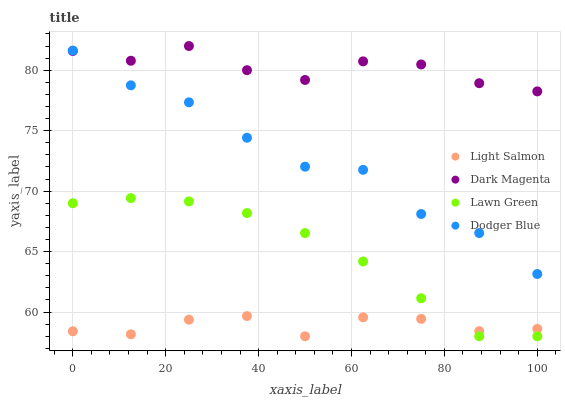Does Light Salmon have the minimum area under the curve?
Answer yes or no. Yes. Does Dark Magenta have the maximum area under the curve?
Answer yes or no. Yes. Does Dodger Blue have the minimum area under the curve?
Answer yes or no. No. Does Dodger Blue have the maximum area under the curve?
Answer yes or no. No. Is Lawn Green the smoothest?
Answer yes or no. Yes. Is Dodger Blue the roughest?
Answer yes or no. Yes. Is Light Salmon the smoothest?
Answer yes or no. No. Is Light Salmon the roughest?
Answer yes or no. No. Does Lawn Green have the lowest value?
Answer yes or no. Yes. Does Dodger Blue have the lowest value?
Answer yes or no. No. Does Dark Magenta have the highest value?
Answer yes or no. Yes. Does Dodger Blue have the highest value?
Answer yes or no. No. Is Lawn Green less than Dark Magenta?
Answer yes or no. Yes. Is Dodger Blue greater than Lawn Green?
Answer yes or no. Yes. Does Dodger Blue intersect Dark Magenta?
Answer yes or no. Yes. Is Dodger Blue less than Dark Magenta?
Answer yes or no. No. Is Dodger Blue greater than Dark Magenta?
Answer yes or no. No. Does Lawn Green intersect Dark Magenta?
Answer yes or no. No. 